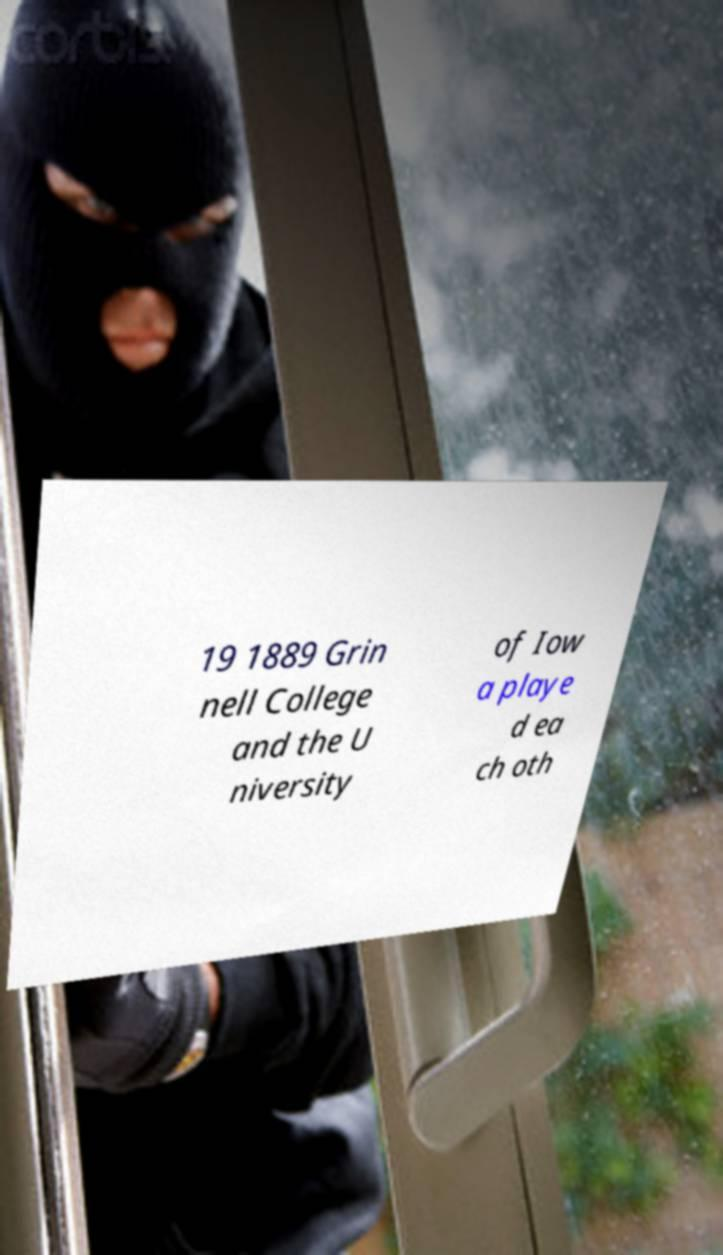There's text embedded in this image that I need extracted. Can you transcribe it verbatim? 19 1889 Grin nell College and the U niversity of Iow a playe d ea ch oth 